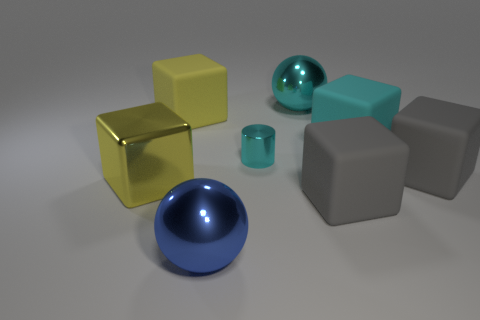There is a matte object that is left of the small cylinder; is it the same size as the cyan metal cylinder that is right of the big yellow matte object?
Give a very brief answer. No. What number of things are large cyan objects or cubes to the right of the blue sphere?
Provide a short and direct response. 4. Are there any other big matte things of the same shape as the cyan matte object?
Give a very brief answer. Yes. There is a thing on the left side of the big matte cube that is left of the blue ball; how big is it?
Keep it short and to the point. Large. How many shiny objects are either brown cylinders or big blue things?
Your answer should be very brief. 1. How many yellow objects are there?
Ensure brevity in your answer.  2. Is the material of the cyan object that is on the right side of the big cyan metallic sphere the same as the large yellow cube behind the cylinder?
Provide a succinct answer. Yes. There is a metallic object that is the same shape as the large cyan matte object; what is its color?
Your answer should be very brief. Yellow. What material is the sphere behind the gray cube behind the large yellow shiny block?
Offer a terse response. Metal. Is the shape of the metal thing that is in front of the large shiny block the same as the cyan metallic object that is behind the cyan shiny cylinder?
Your response must be concise. Yes. 